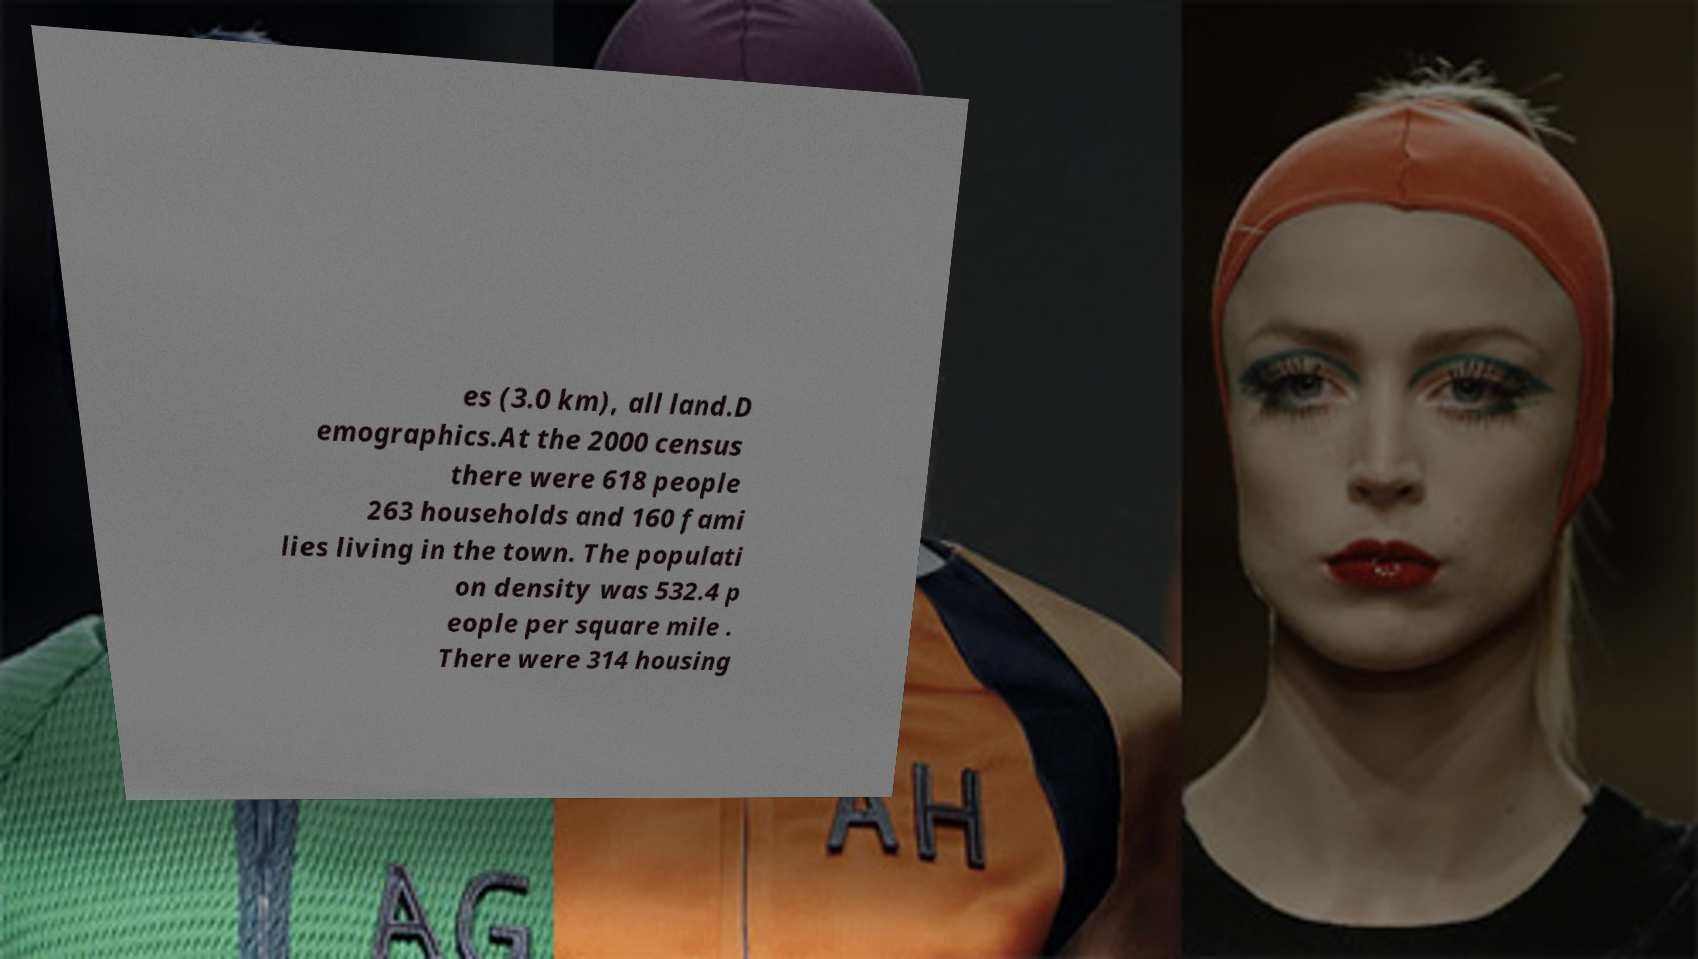Could you assist in decoding the text presented in this image and type it out clearly? es (3.0 km), all land.D emographics.At the 2000 census there were 618 people 263 households and 160 fami lies living in the town. The populati on density was 532.4 p eople per square mile . There were 314 housing 